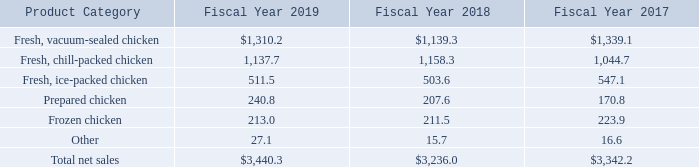2. Disaggregation of Revenue
The following table disaggregates our net sales by product category (in millions):
What is the net sales from Fresh, vacuum-sealed chicken for fiscal years 2019 to 2017 respectively?
Answer scale should be: million. $1,310.2, $1,139.3, $1,339.1. What is the net sales from Fresh, chill-packed chicken for fiscal years 2019 to 2017 respectively?
Answer scale should be: million. 1,137.7, 1,158.3, 1,044.7. What is the net sales from Fresh, ice-packed chicken for fiscal years 2019 to 2017 respectively?
Answer scale should be: million. 511.5, 503.6, 547.1. What is the average net sales from Fresh, ice-packed chicken for fiscal years 2019 to 2017?
Answer scale should be: million. (511.5+503.6+547.1)/3
Answer: 520.73. What is the change in value of frozen chicken between fiscal year 2019 and 2018?
Answer scale should be: million. 213.0-211.5
Answer: 1.5. What is the average net sales from Fresh, chill-packed chicken for fiscal years 2019 to 2017?
Answer scale should be: million. (1,137.7+1,158.3+1,044.7)/3
Answer: 1113.57. 